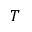Convert formula to latex. <formula><loc_0><loc_0><loc_500><loc_500>T</formula> 